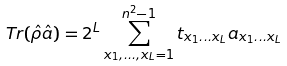<formula> <loc_0><loc_0><loc_500><loc_500>T r ( \hat { \rho } \hat { a } ) = 2 ^ { L } \sum _ { x _ { 1 } , \dots , x _ { L } = 1 } ^ { n ^ { 2 } - 1 } t _ { x _ { 1 } \dots x _ { L } } a _ { x _ { 1 } \dots x _ { L } }</formula> 